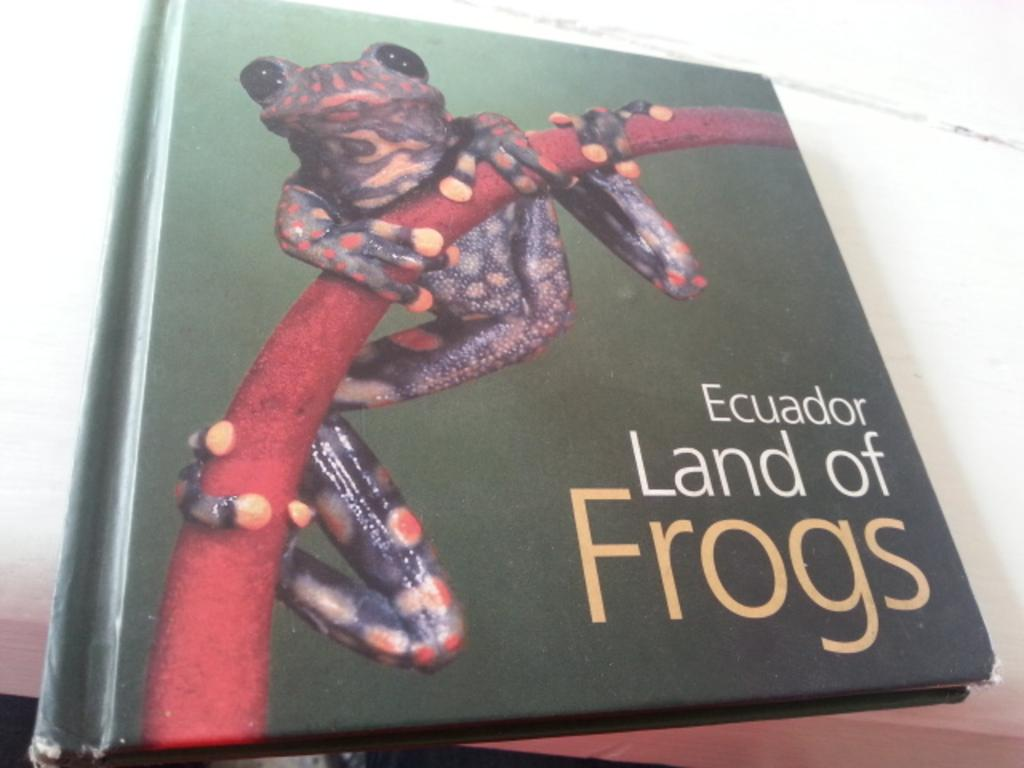<image>
Give a short and clear explanation of the subsequent image. Ecuador Land of Frogs book containing a colored frog. 